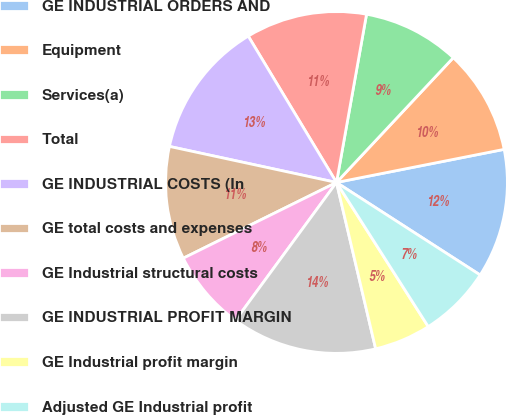Convert chart. <chart><loc_0><loc_0><loc_500><loc_500><pie_chart><fcel>GE INDUSTRIAL ORDERS AND<fcel>Equipment<fcel>Services(a)<fcel>Total<fcel>GE INDUSTRIAL COSTS (In<fcel>GE total costs and expenses<fcel>GE Industrial structural costs<fcel>GE INDUSTRIAL PROFIT MARGIN<fcel>GE Industrial profit margin<fcel>Adjusted GE Industrial profit<nl><fcel>12.21%<fcel>9.92%<fcel>9.16%<fcel>11.45%<fcel>12.98%<fcel>10.69%<fcel>7.63%<fcel>13.74%<fcel>5.34%<fcel>6.87%<nl></chart> 